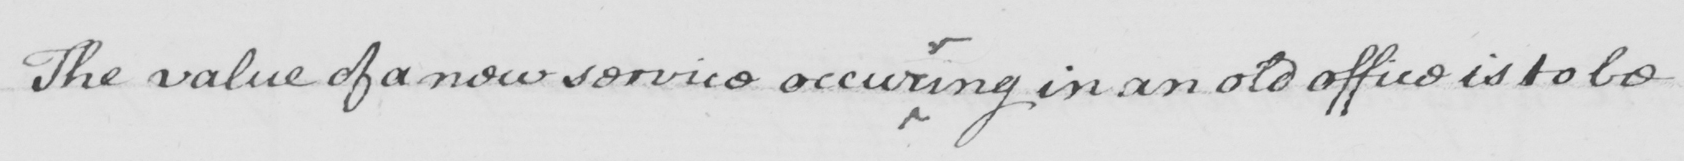What text is written in this handwritten line? The value of a new service occur ing in an old office is to be 